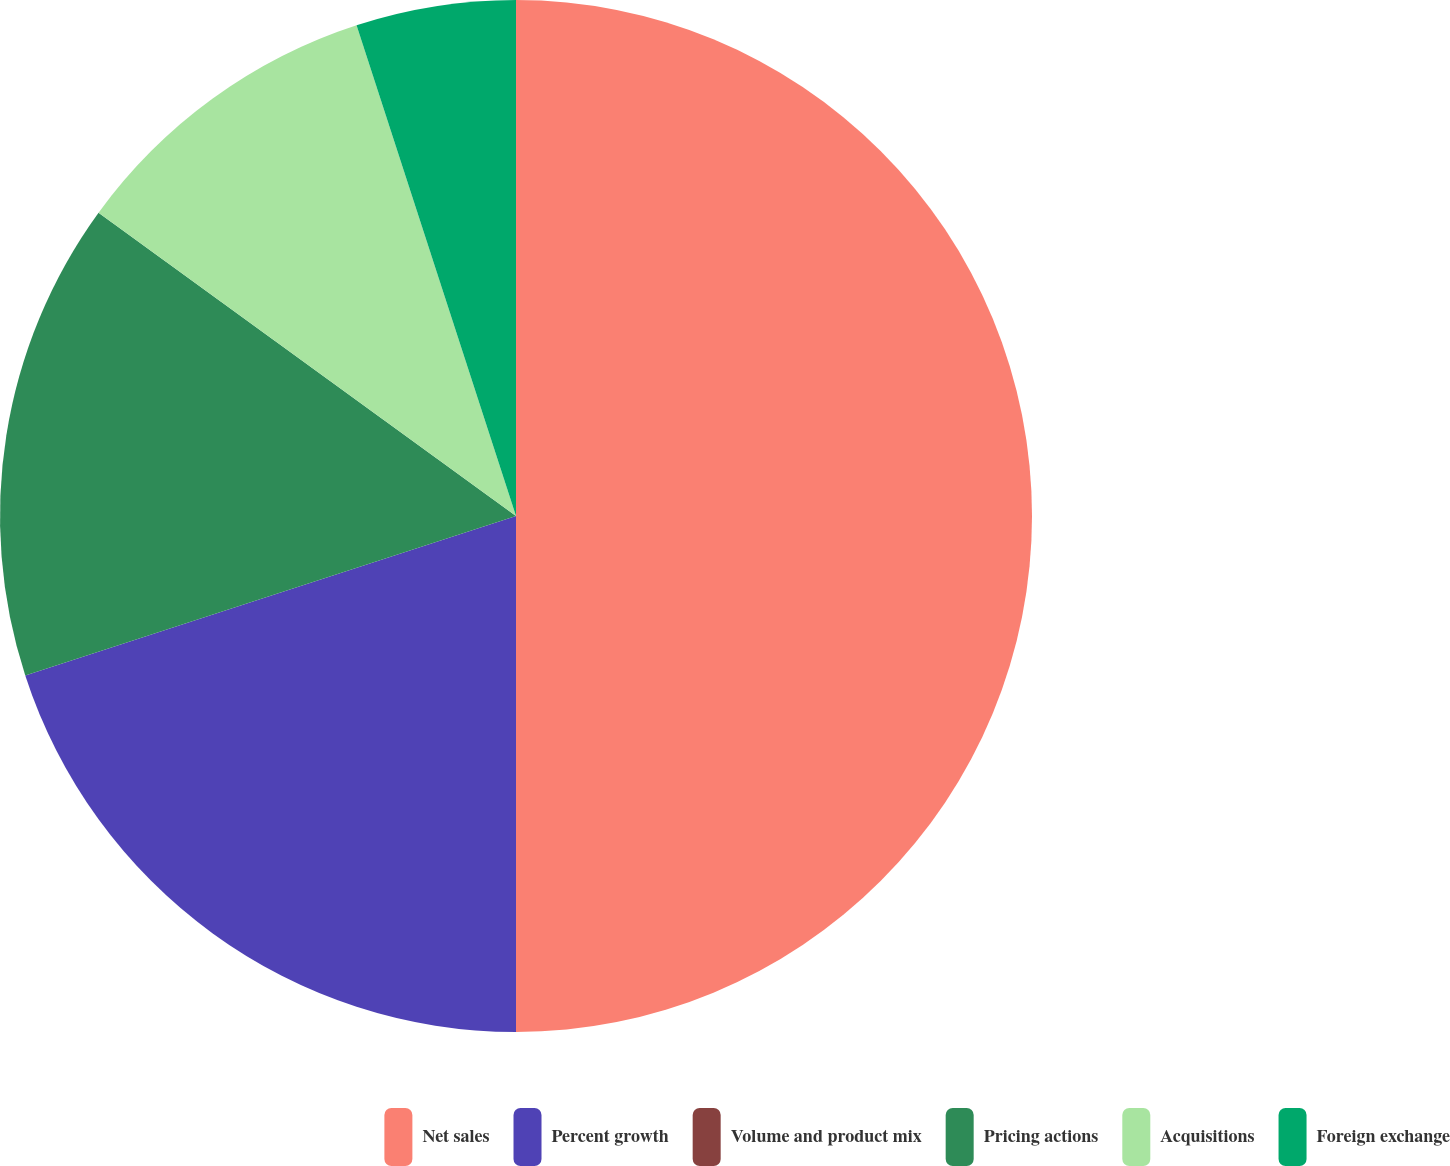Convert chart. <chart><loc_0><loc_0><loc_500><loc_500><pie_chart><fcel>Net sales<fcel>Percent growth<fcel>Volume and product mix<fcel>Pricing actions<fcel>Acquisitions<fcel>Foreign exchange<nl><fcel>50.0%<fcel>20.0%<fcel>0.0%<fcel>15.0%<fcel>10.0%<fcel>5.0%<nl></chart> 